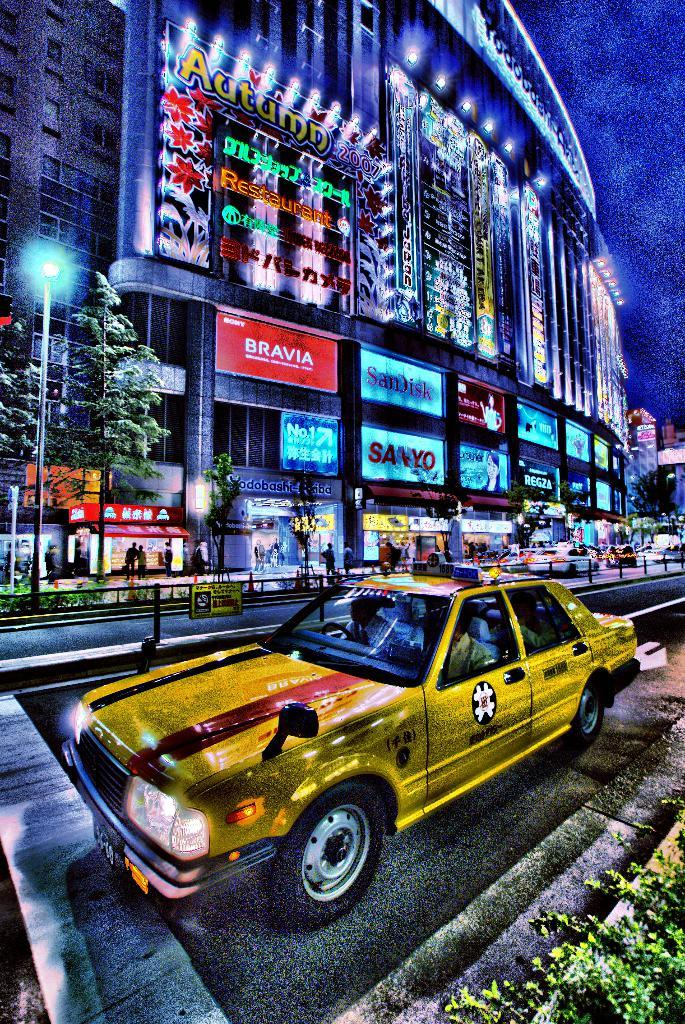<image>
Summarize the visual content of the image. A highly colorized image of a taxi on a busy city street across from a large building with a sign saying Autumn 2007 on it. 